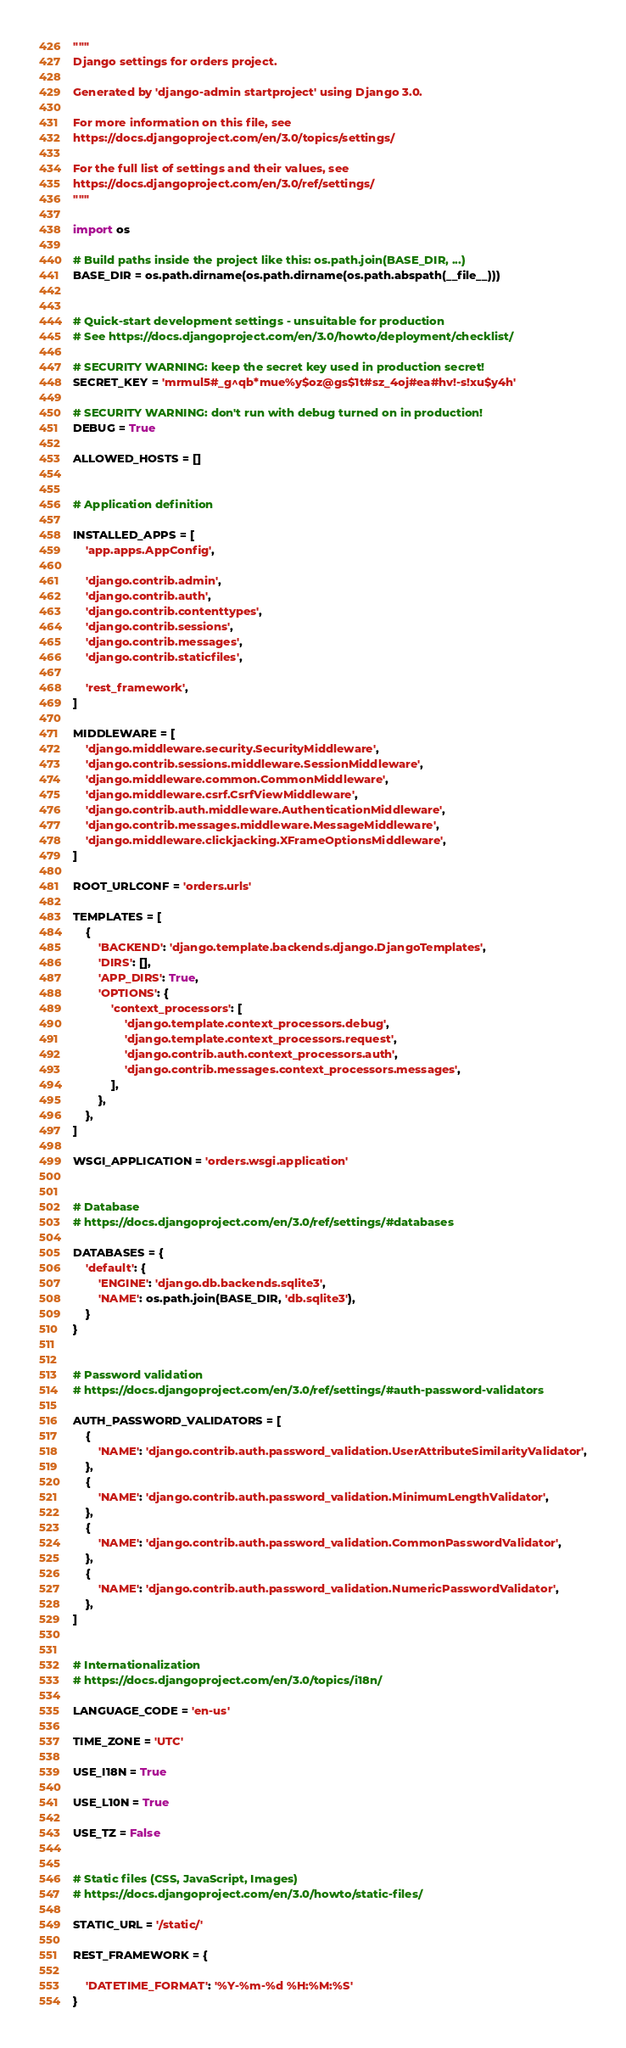<code> <loc_0><loc_0><loc_500><loc_500><_Python_>"""
Django settings for orders project.

Generated by 'django-admin startproject' using Django 3.0.

For more information on this file, see
https://docs.djangoproject.com/en/3.0/topics/settings/

For the full list of settings and their values, see
https://docs.djangoproject.com/en/3.0/ref/settings/
"""

import os

# Build paths inside the project like this: os.path.join(BASE_DIR, ...)
BASE_DIR = os.path.dirname(os.path.dirname(os.path.abspath(__file__)))


# Quick-start development settings - unsuitable for production
# See https://docs.djangoproject.com/en/3.0/howto/deployment/checklist/

# SECURITY WARNING: keep the secret key used in production secret!
SECRET_KEY = 'mrmul5#_g^qb*mue%y$oz@gs$1t#sz_4oj#ea#hv!-s!xu$y4h'

# SECURITY WARNING: don't run with debug turned on in production!
DEBUG = True

ALLOWED_HOSTS = []


# Application definition

INSTALLED_APPS = [
    'app.apps.AppConfig',

    'django.contrib.admin',
    'django.contrib.auth',
    'django.contrib.contenttypes',
    'django.contrib.sessions',
    'django.contrib.messages',
    'django.contrib.staticfiles',

    'rest_framework',
]

MIDDLEWARE = [
    'django.middleware.security.SecurityMiddleware',
    'django.contrib.sessions.middleware.SessionMiddleware',
    'django.middleware.common.CommonMiddleware',
    'django.middleware.csrf.CsrfViewMiddleware',
    'django.contrib.auth.middleware.AuthenticationMiddleware',
    'django.contrib.messages.middleware.MessageMiddleware',
    'django.middleware.clickjacking.XFrameOptionsMiddleware',
]

ROOT_URLCONF = 'orders.urls'

TEMPLATES = [
    {
        'BACKEND': 'django.template.backends.django.DjangoTemplates',
        'DIRS': [],
        'APP_DIRS': True,
        'OPTIONS': {
            'context_processors': [
                'django.template.context_processors.debug',
                'django.template.context_processors.request',
                'django.contrib.auth.context_processors.auth',
                'django.contrib.messages.context_processors.messages',
            ],
        },
    },
]

WSGI_APPLICATION = 'orders.wsgi.application'


# Database
# https://docs.djangoproject.com/en/3.0/ref/settings/#databases

DATABASES = {
    'default': {
        'ENGINE': 'django.db.backends.sqlite3',
        'NAME': os.path.join(BASE_DIR, 'db.sqlite3'),
    }
}


# Password validation
# https://docs.djangoproject.com/en/3.0/ref/settings/#auth-password-validators

AUTH_PASSWORD_VALIDATORS = [
    {
        'NAME': 'django.contrib.auth.password_validation.UserAttributeSimilarityValidator',
    },
    {
        'NAME': 'django.contrib.auth.password_validation.MinimumLengthValidator',
    },
    {
        'NAME': 'django.contrib.auth.password_validation.CommonPasswordValidator',
    },
    {
        'NAME': 'django.contrib.auth.password_validation.NumericPasswordValidator',
    },
]


# Internationalization
# https://docs.djangoproject.com/en/3.0/topics/i18n/

LANGUAGE_CODE = 'en-us'

TIME_ZONE = 'UTC'

USE_I18N = True

USE_L10N = True

USE_TZ = False


# Static files (CSS, JavaScript, Images)
# https://docs.djangoproject.com/en/3.0/howto/static-files/

STATIC_URL = '/static/'

REST_FRAMEWORK = {

    'DATETIME_FORMAT': '%Y-%m-%d %H:%M:%S'
}
</code> 